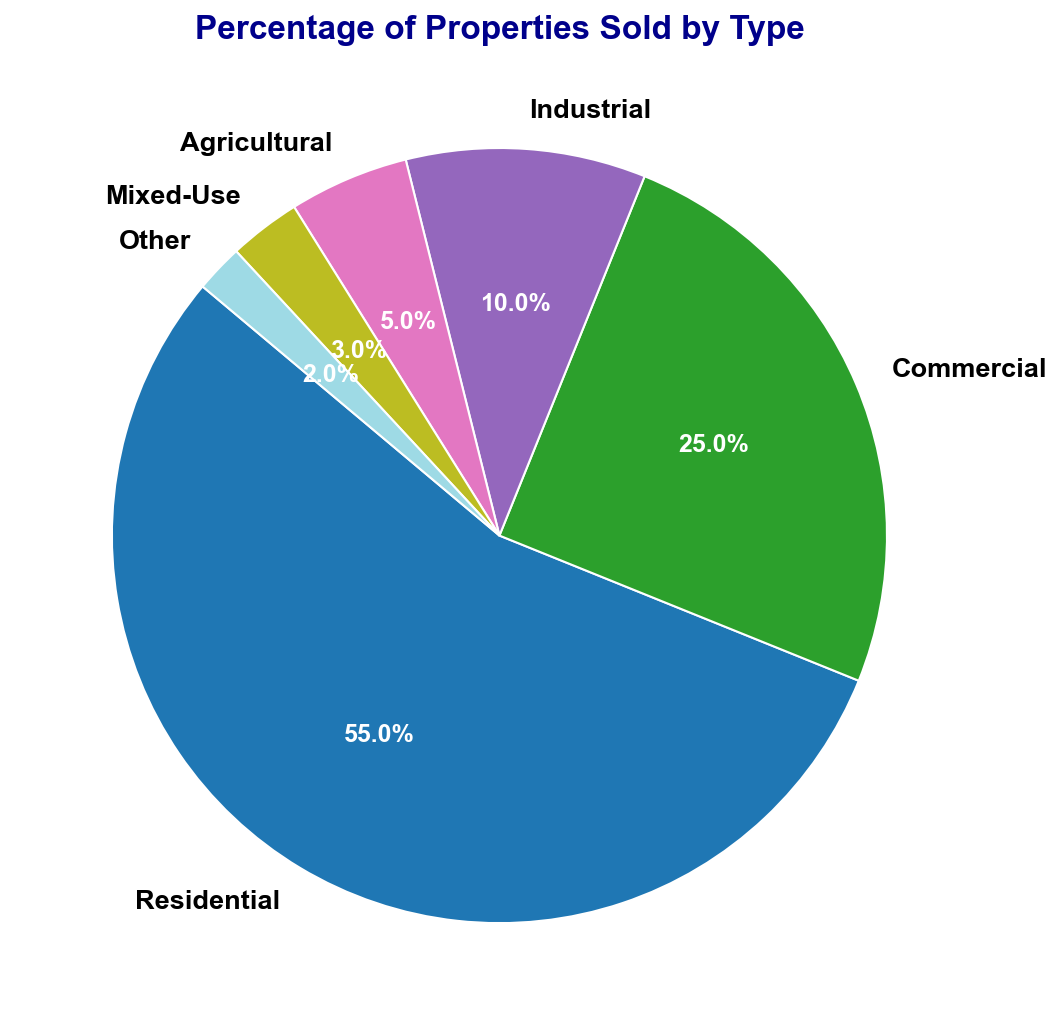what percentage of properties sold are residential? We look at the slice labeled "Residential" on the pie chart, which shows 55%.
Answer: 55% how much more percentage do commercial properties contribute to the total compared to industrial properties? The pie chart shows Commercial properties at 25% and Industrial properties at 10%. The difference is 25% - 10% = 15%.
Answer: 15% what is the combined percentage of agricultural and mixed-use properties sold? The percentage of Agricultural properties sold is 5%, and the percentage for Mixed-Use is 3%. Adding these gives 5% + 3% = 8%.
Answer: 8% which property type has the lowest percentage of sales and what is that percentage? The pie chart indicates that "Other" has the lowest percentage of sales, labeled as 2%.
Answer: Other, 2% which property type has a larger percentage share: agricultural or industrial? The pie chart shows Industrial properties at 10% and Agricultural properties at 5%. Therefore, Industrial has a larger percentage.
Answer: Industrial what is the relative size difference between the residential and commercial property slices? The Residential slice is 55%, and the Commercial slice is 25%. To find the relative size difference: (55% / 25%) = 2.2. Residential is 2.2 times larger than Commercial.
Answer: Residential is 2.2 times larger than Commercial is the total percentage of mixed-use, agricultural, and other properties sold greater than or less than the percentage of commercial properties sold? Adding the percentages of Mixed-Use (3%), Agricultural (5%), and Other (2%) gives 3% + 5% + 2% = 10%. This is less than the percentage for Commercial properties, which is 25%.
Answer: Less than how many property types have a percentage of sales that is greater than 10%? By inspecting the pie chart, we see that Residential (55%) and Commercial (25%) each have a percentage greater than 10%.
Answer: 2 